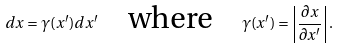<formula> <loc_0><loc_0><loc_500><loc_500>d x = \gamma ( x ^ { \prime } ) d x ^ { \prime } \quad \text {where} \quad \gamma ( x ^ { \prime } ) = \left | \frac { \partial x } { \partial x ^ { \prime } } \right | .</formula> 